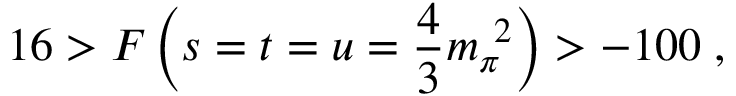<formula> <loc_0><loc_0><loc_500><loc_500>1 6 > F \left ( s = t = u = \frac { 4 } { 3 } m _ { \pi } ^ { \ 2 } \right ) > - 1 0 0 \, ,</formula> 